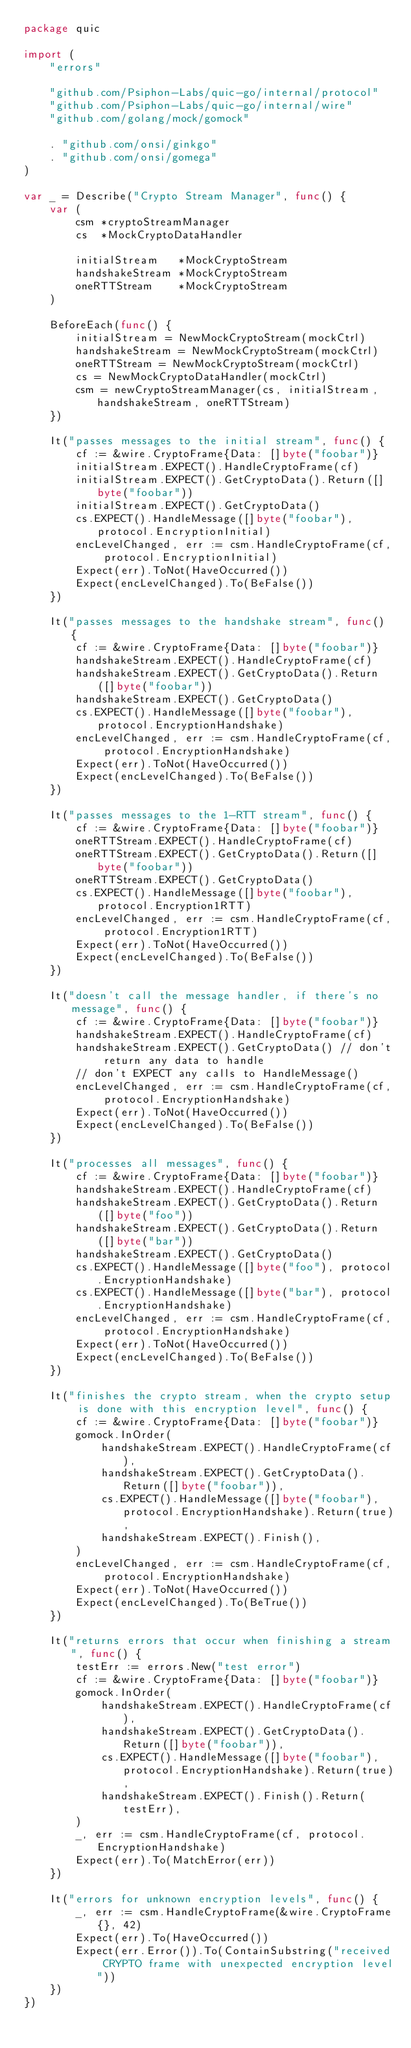<code> <loc_0><loc_0><loc_500><loc_500><_Go_>package quic

import (
	"errors"

	"github.com/Psiphon-Labs/quic-go/internal/protocol"
	"github.com/Psiphon-Labs/quic-go/internal/wire"
	"github.com/golang/mock/gomock"

	. "github.com/onsi/ginkgo"
	. "github.com/onsi/gomega"
)

var _ = Describe("Crypto Stream Manager", func() {
	var (
		csm *cryptoStreamManager
		cs  *MockCryptoDataHandler

		initialStream   *MockCryptoStream
		handshakeStream *MockCryptoStream
		oneRTTStream    *MockCryptoStream
	)

	BeforeEach(func() {
		initialStream = NewMockCryptoStream(mockCtrl)
		handshakeStream = NewMockCryptoStream(mockCtrl)
		oneRTTStream = NewMockCryptoStream(mockCtrl)
		cs = NewMockCryptoDataHandler(mockCtrl)
		csm = newCryptoStreamManager(cs, initialStream, handshakeStream, oneRTTStream)
	})

	It("passes messages to the initial stream", func() {
		cf := &wire.CryptoFrame{Data: []byte("foobar")}
		initialStream.EXPECT().HandleCryptoFrame(cf)
		initialStream.EXPECT().GetCryptoData().Return([]byte("foobar"))
		initialStream.EXPECT().GetCryptoData()
		cs.EXPECT().HandleMessage([]byte("foobar"), protocol.EncryptionInitial)
		encLevelChanged, err := csm.HandleCryptoFrame(cf, protocol.EncryptionInitial)
		Expect(err).ToNot(HaveOccurred())
		Expect(encLevelChanged).To(BeFalse())
	})

	It("passes messages to the handshake stream", func() {
		cf := &wire.CryptoFrame{Data: []byte("foobar")}
		handshakeStream.EXPECT().HandleCryptoFrame(cf)
		handshakeStream.EXPECT().GetCryptoData().Return([]byte("foobar"))
		handshakeStream.EXPECT().GetCryptoData()
		cs.EXPECT().HandleMessage([]byte("foobar"), protocol.EncryptionHandshake)
		encLevelChanged, err := csm.HandleCryptoFrame(cf, protocol.EncryptionHandshake)
		Expect(err).ToNot(HaveOccurred())
		Expect(encLevelChanged).To(BeFalse())
	})

	It("passes messages to the 1-RTT stream", func() {
		cf := &wire.CryptoFrame{Data: []byte("foobar")}
		oneRTTStream.EXPECT().HandleCryptoFrame(cf)
		oneRTTStream.EXPECT().GetCryptoData().Return([]byte("foobar"))
		oneRTTStream.EXPECT().GetCryptoData()
		cs.EXPECT().HandleMessage([]byte("foobar"), protocol.Encryption1RTT)
		encLevelChanged, err := csm.HandleCryptoFrame(cf, protocol.Encryption1RTT)
		Expect(err).ToNot(HaveOccurred())
		Expect(encLevelChanged).To(BeFalse())
	})

	It("doesn't call the message handler, if there's no message", func() {
		cf := &wire.CryptoFrame{Data: []byte("foobar")}
		handshakeStream.EXPECT().HandleCryptoFrame(cf)
		handshakeStream.EXPECT().GetCryptoData() // don't return any data to handle
		// don't EXPECT any calls to HandleMessage()
		encLevelChanged, err := csm.HandleCryptoFrame(cf, protocol.EncryptionHandshake)
		Expect(err).ToNot(HaveOccurred())
		Expect(encLevelChanged).To(BeFalse())
	})

	It("processes all messages", func() {
		cf := &wire.CryptoFrame{Data: []byte("foobar")}
		handshakeStream.EXPECT().HandleCryptoFrame(cf)
		handshakeStream.EXPECT().GetCryptoData().Return([]byte("foo"))
		handshakeStream.EXPECT().GetCryptoData().Return([]byte("bar"))
		handshakeStream.EXPECT().GetCryptoData()
		cs.EXPECT().HandleMessage([]byte("foo"), protocol.EncryptionHandshake)
		cs.EXPECT().HandleMessage([]byte("bar"), protocol.EncryptionHandshake)
		encLevelChanged, err := csm.HandleCryptoFrame(cf, protocol.EncryptionHandshake)
		Expect(err).ToNot(HaveOccurred())
		Expect(encLevelChanged).To(BeFalse())
	})

	It("finishes the crypto stream, when the crypto setup is done with this encryption level", func() {
		cf := &wire.CryptoFrame{Data: []byte("foobar")}
		gomock.InOrder(
			handshakeStream.EXPECT().HandleCryptoFrame(cf),
			handshakeStream.EXPECT().GetCryptoData().Return([]byte("foobar")),
			cs.EXPECT().HandleMessage([]byte("foobar"), protocol.EncryptionHandshake).Return(true),
			handshakeStream.EXPECT().Finish(),
		)
		encLevelChanged, err := csm.HandleCryptoFrame(cf, protocol.EncryptionHandshake)
		Expect(err).ToNot(HaveOccurred())
		Expect(encLevelChanged).To(BeTrue())
	})

	It("returns errors that occur when finishing a stream", func() {
		testErr := errors.New("test error")
		cf := &wire.CryptoFrame{Data: []byte("foobar")}
		gomock.InOrder(
			handshakeStream.EXPECT().HandleCryptoFrame(cf),
			handshakeStream.EXPECT().GetCryptoData().Return([]byte("foobar")),
			cs.EXPECT().HandleMessage([]byte("foobar"), protocol.EncryptionHandshake).Return(true),
			handshakeStream.EXPECT().Finish().Return(testErr),
		)
		_, err := csm.HandleCryptoFrame(cf, protocol.EncryptionHandshake)
		Expect(err).To(MatchError(err))
	})

	It("errors for unknown encryption levels", func() {
		_, err := csm.HandleCryptoFrame(&wire.CryptoFrame{}, 42)
		Expect(err).To(HaveOccurred())
		Expect(err.Error()).To(ContainSubstring("received CRYPTO frame with unexpected encryption level"))
	})
})
</code> 